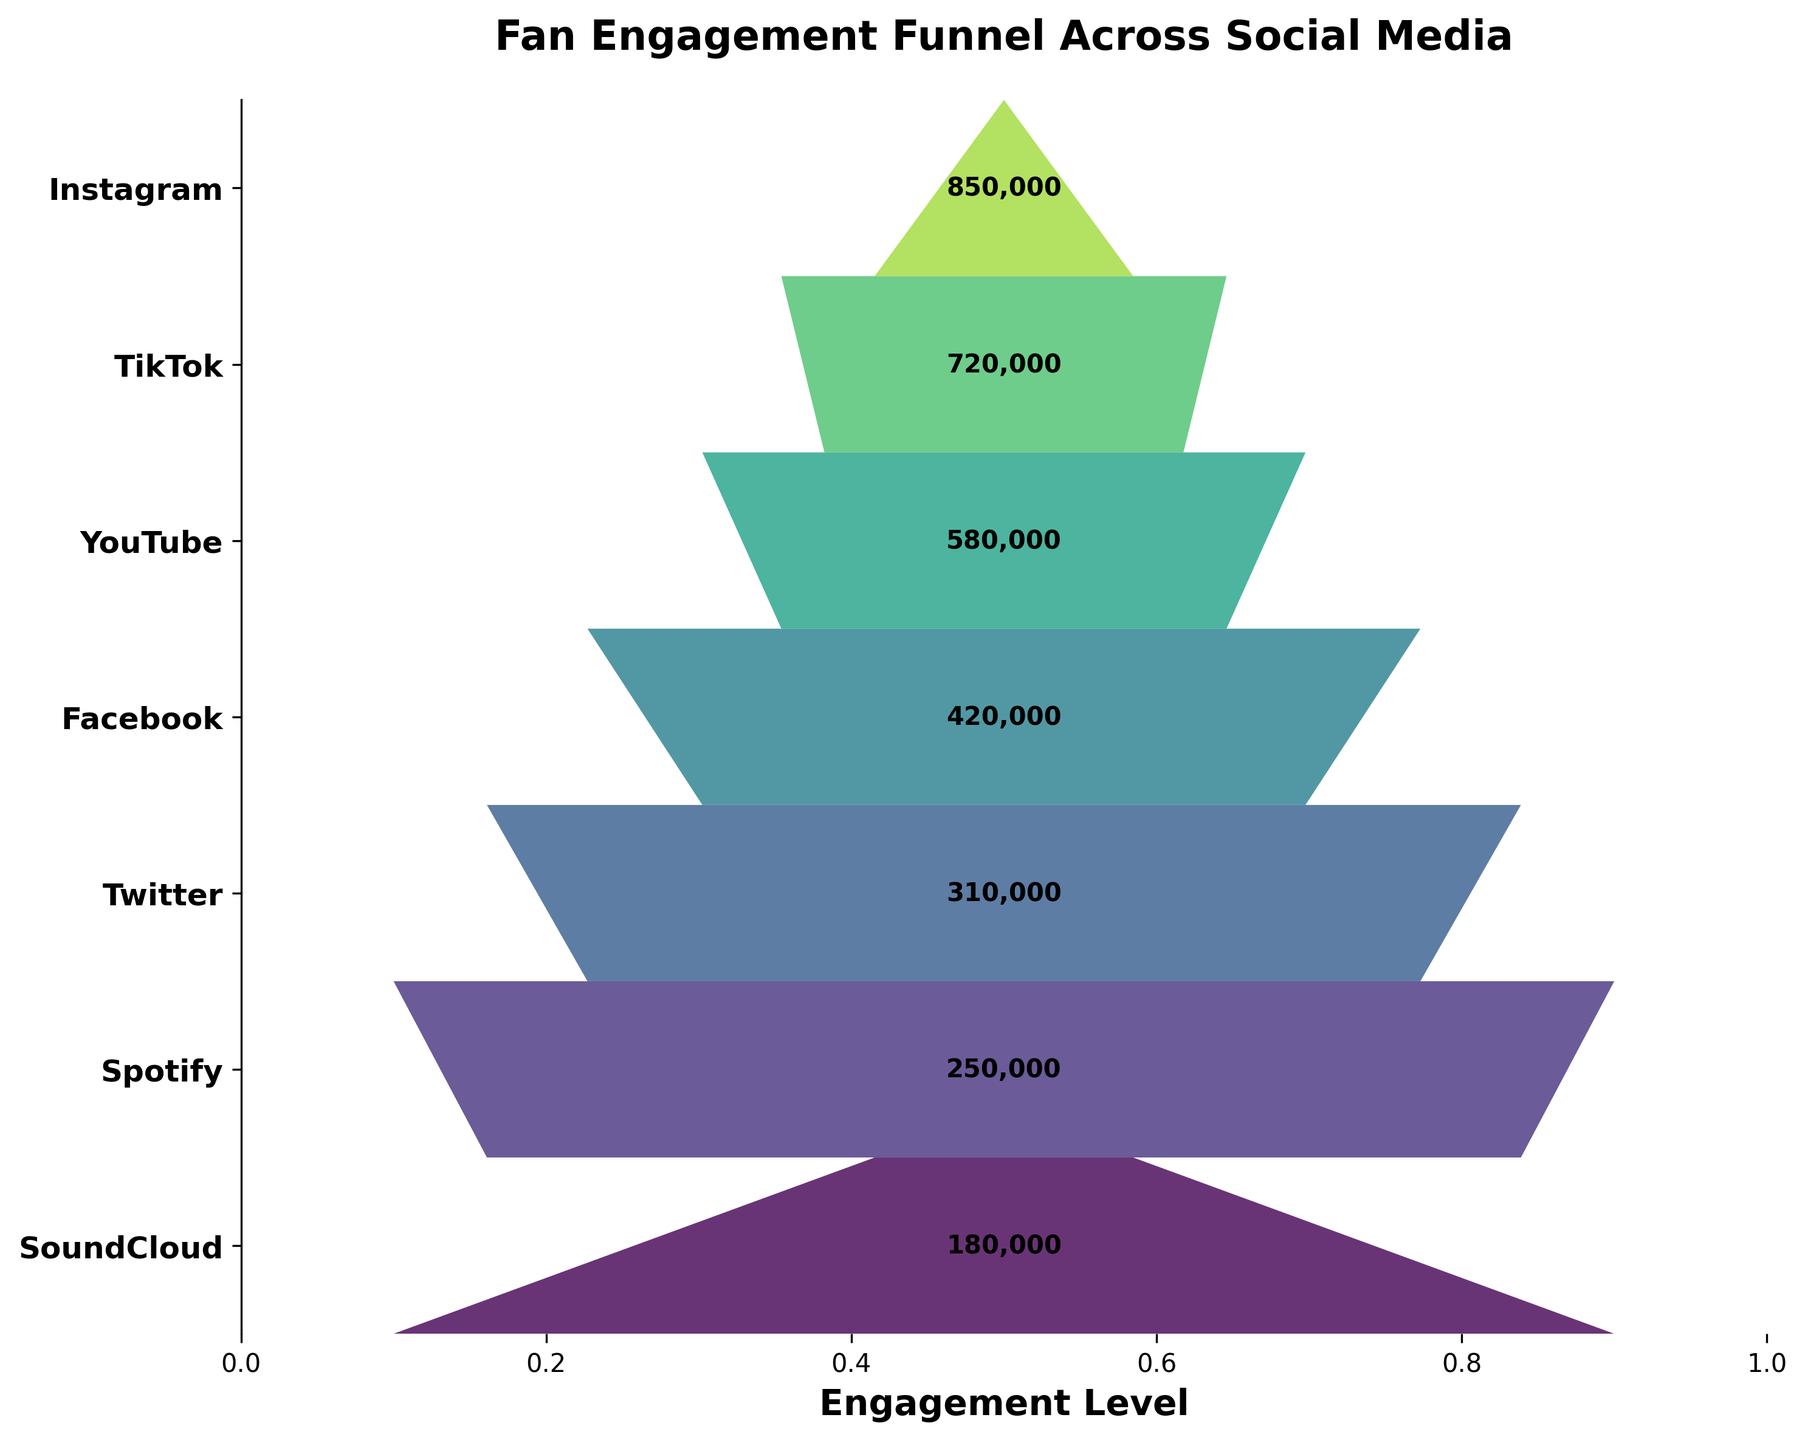Which social media platform has the highest fan engagement? The figure shows the width of the funnel segments representing engagement levels. The widest segment is at the top for Instagram.
Answer: Instagram Which platform has the lowest engagement level? The bottom segment of the funnel represents the platform with the lowest engagement level, which is SoundCloud.
Answer: SoundCloud How many engagement levels are displayed on the chart? Counting the distinct funnel segments from top to bottom gives the total number of engagement levels shown. There are 7 segments.
Answer: 7 What is the combined engagement level of Facebook and Twitter? Referring to the engagement values from the chart: Facebook has 420,000 and Twitter has 310,000. Their sum is 420,000 + 310,000 = 730,000.
Answer: 730,000 What is the engagement difference between TikTok and Spotify? TikTok has 720,000 engagements and Spotify has 250,000. The difference is 720,000 - 250,000 = 470,000.
Answer: 470,000 How does the engagement level of YouTube compare to that of SoundCloud? YouTube has 580,000 engagements, and SoundCloud has 180,000. YouTube's engagement level is significantly higher.
Answer: YouTube's engagement is higher What is the average engagement level across all platforms? Adding all engagement levels: 850,000 (Instagram) + 720,000 (TikTok) + 580,000 (YouTube) + 420,000 (Facebook) + 310,000 (Twitter) + 250,000 (Spotify) + 180,000 (SoundCloud) = 3,310,000. Dividing by the number of platforms (7) gives the average: 3,310,000 / 7 ≈ 472,857.
Answer: 472,857 Which platforms have engagement levels greater than 500,000? By examining the engagement levels, Instagram (850,000), TikTok (720,000), and YouTube (580,000) are greater than 500,000.
Answer: Instagram, TikTok, YouTube What is the sum of the engagement levels of the four least engaging platforms? The four least engaging platforms are Twitter (310,000), Spotify (250,000), and SoundCloud (180,000). Their sum is: 310,000 + 250,000 + 180,000 = 740,000.
Answer: 740,000 